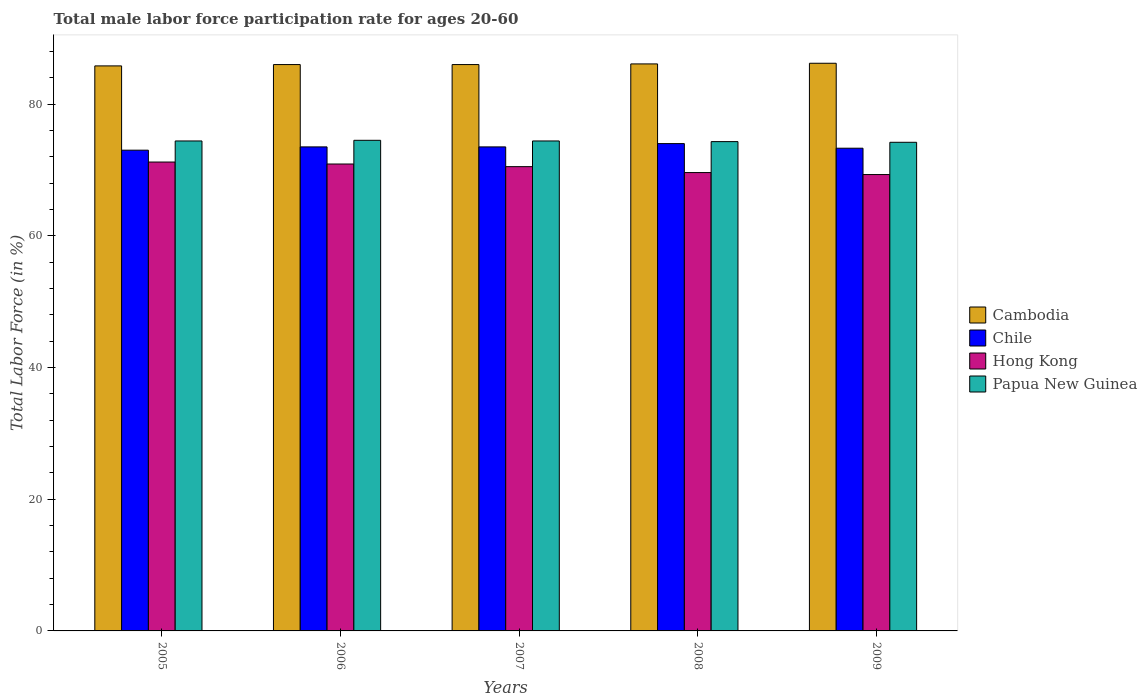How many different coloured bars are there?
Give a very brief answer. 4. How many bars are there on the 2nd tick from the right?
Offer a very short reply. 4. What is the label of the 1st group of bars from the left?
Keep it short and to the point. 2005. In how many cases, is the number of bars for a given year not equal to the number of legend labels?
Your answer should be very brief. 0. What is the male labor force participation rate in Hong Kong in 2006?
Your answer should be compact. 70.9. Across all years, what is the maximum male labor force participation rate in Cambodia?
Make the answer very short. 86.2. Across all years, what is the minimum male labor force participation rate in Chile?
Offer a very short reply. 73. In which year was the male labor force participation rate in Hong Kong minimum?
Your answer should be very brief. 2009. What is the total male labor force participation rate in Hong Kong in the graph?
Offer a terse response. 351.5. What is the difference between the male labor force participation rate in Cambodia in 2007 and that in 2009?
Keep it short and to the point. -0.2. What is the difference between the male labor force participation rate in Cambodia in 2008 and the male labor force participation rate in Chile in 2009?
Your answer should be compact. 12.8. What is the average male labor force participation rate in Cambodia per year?
Give a very brief answer. 86.02. In the year 2009, what is the difference between the male labor force participation rate in Papua New Guinea and male labor force participation rate in Hong Kong?
Offer a terse response. 4.9. What is the ratio of the male labor force participation rate in Cambodia in 2008 to that in 2009?
Provide a short and direct response. 1. Is the male labor force participation rate in Cambodia in 2005 less than that in 2006?
Ensure brevity in your answer.  Yes. What is the difference between the highest and the lowest male labor force participation rate in Papua New Guinea?
Offer a terse response. 0.3. Is the sum of the male labor force participation rate in Hong Kong in 2006 and 2009 greater than the maximum male labor force participation rate in Papua New Guinea across all years?
Provide a short and direct response. Yes. Is it the case that in every year, the sum of the male labor force participation rate in Papua New Guinea and male labor force participation rate in Cambodia is greater than the sum of male labor force participation rate in Chile and male labor force participation rate in Hong Kong?
Give a very brief answer. Yes. What does the 4th bar from the left in 2008 represents?
Your response must be concise. Papua New Guinea. What does the 4th bar from the right in 2009 represents?
Your response must be concise. Cambodia. How many bars are there?
Your answer should be very brief. 20. How many years are there in the graph?
Provide a succinct answer. 5. What is the difference between two consecutive major ticks on the Y-axis?
Provide a succinct answer. 20. Does the graph contain any zero values?
Your answer should be very brief. No. Where does the legend appear in the graph?
Offer a terse response. Center right. How are the legend labels stacked?
Give a very brief answer. Vertical. What is the title of the graph?
Keep it short and to the point. Total male labor force participation rate for ages 20-60. What is the label or title of the X-axis?
Give a very brief answer. Years. What is the Total Labor Force (in %) of Cambodia in 2005?
Your answer should be very brief. 85.8. What is the Total Labor Force (in %) of Chile in 2005?
Offer a terse response. 73. What is the Total Labor Force (in %) of Hong Kong in 2005?
Your answer should be very brief. 71.2. What is the Total Labor Force (in %) of Papua New Guinea in 2005?
Provide a short and direct response. 74.4. What is the Total Labor Force (in %) in Chile in 2006?
Ensure brevity in your answer.  73.5. What is the Total Labor Force (in %) of Hong Kong in 2006?
Offer a terse response. 70.9. What is the Total Labor Force (in %) in Papua New Guinea in 2006?
Your answer should be very brief. 74.5. What is the Total Labor Force (in %) in Chile in 2007?
Ensure brevity in your answer.  73.5. What is the Total Labor Force (in %) of Hong Kong in 2007?
Your response must be concise. 70.5. What is the Total Labor Force (in %) in Papua New Guinea in 2007?
Your answer should be very brief. 74.4. What is the Total Labor Force (in %) of Cambodia in 2008?
Offer a terse response. 86.1. What is the Total Labor Force (in %) of Hong Kong in 2008?
Provide a succinct answer. 69.6. What is the Total Labor Force (in %) of Papua New Guinea in 2008?
Provide a succinct answer. 74.3. What is the Total Labor Force (in %) in Cambodia in 2009?
Offer a terse response. 86.2. What is the Total Labor Force (in %) in Chile in 2009?
Ensure brevity in your answer.  73.3. What is the Total Labor Force (in %) in Hong Kong in 2009?
Provide a short and direct response. 69.3. What is the Total Labor Force (in %) of Papua New Guinea in 2009?
Provide a succinct answer. 74.2. Across all years, what is the maximum Total Labor Force (in %) of Cambodia?
Your answer should be very brief. 86.2. Across all years, what is the maximum Total Labor Force (in %) of Chile?
Make the answer very short. 74. Across all years, what is the maximum Total Labor Force (in %) in Hong Kong?
Ensure brevity in your answer.  71.2. Across all years, what is the maximum Total Labor Force (in %) of Papua New Guinea?
Provide a succinct answer. 74.5. Across all years, what is the minimum Total Labor Force (in %) of Cambodia?
Offer a terse response. 85.8. Across all years, what is the minimum Total Labor Force (in %) of Chile?
Make the answer very short. 73. Across all years, what is the minimum Total Labor Force (in %) of Hong Kong?
Keep it short and to the point. 69.3. Across all years, what is the minimum Total Labor Force (in %) in Papua New Guinea?
Your answer should be compact. 74.2. What is the total Total Labor Force (in %) of Cambodia in the graph?
Ensure brevity in your answer.  430.1. What is the total Total Labor Force (in %) of Chile in the graph?
Your answer should be very brief. 367.3. What is the total Total Labor Force (in %) of Hong Kong in the graph?
Make the answer very short. 351.5. What is the total Total Labor Force (in %) of Papua New Guinea in the graph?
Provide a succinct answer. 371.8. What is the difference between the Total Labor Force (in %) in Cambodia in 2005 and that in 2007?
Keep it short and to the point. -0.2. What is the difference between the Total Labor Force (in %) of Hong Kong in 2005 and that in 2007?
Offer a very short reply. 0.7. What is the difference between the Total Labor Force (in %) in Cambodia in 2005 and that in 2009?
Your response must be concise. -0.4. What is the difference between the Total Labor Force (in %) in Chile in 2005 and that in 2009?
Give a very brief answer. -0.3. What is the difference between the Total Labor Force (in %) in Hong Kong in 2005 and that in 2009?
Keep it short and to the point. 1.9. What is the difference between the Total Labor Force (in %) in Papua New Guinea in 2005 and that in 2009?
Keep it short and to the point. 0.2. What is the difference between the Total Labor Force (in %) of Chile in 2006 and that in 2007?
Provide a short and direct response. 0. What is the difference between the Total Labor Force (in %) of Chile in 2006 and that in 2008?
Your answer should be very brief. -0.5. What is the difference between the Total Labor Force (in %) in Hong Kong in 2006 and that in 2008?
Make the answer very short. 1.3. What is the difference between the Total Labor Force (in %) in Papua New Guinea in 2006 and that in 2008?
Keep it short and to the point. 0.2. What is the difference between the Total Labor Force (in %) in Chile in 2006 and that in 2009?
Offer a terse response. 0.2. What is the difference between the Total Labor Force (in %) of Hong Kong in 2006 and that in 2009?
Your answer should be very brief. 1.6. What is the difference between the Total Labor Force (in %) in Cambodia in 2007 and that in 2008?
Your response must be concise. -0.1. What is the difference between the Total Labor Force (in %) of Papua New Guinea in 2007 and that in 2008?
Offer a terse response. 0.1. What is the difference between the Total Labor Force (in %) in Cambodia in 2007 and that in 2009?
Make the answer very short. -0.2. What is the difference between the Total Labor Force (in %) in Chile in 2007 and that in 2009?
Your answer should be compact. 0.2. What is the difference between the Total Labor Force (in %) of Hong Kong in 2007 and that in 2009?
Give a very brief answer. 1.2. What is the difference between the Total Labor Force (in %) in Papua New Guinea in 2007 and that in 2009?
Your answer should be very brief. 0.2. What is the difference between the Total Labor Force (in %) in Papua New Guinea in 2008 and that in 2009?
Ensure brevity in your answer.  0.1. What is the difference between the Total Labor Force (in %) of Cambodia in 2005 and the Total Labor Force (in %) of Hong Kong in 2006?
Give a very brief answer. 14.9. What is the difference between the Total Labor Force (in %) of Cambodia in 2005 and the Total Labor Force (in %) of Hong Kong in 2007?
Provide a short and direct response. 15.3. What is the difference between the Total Labor Force (in %) of Cambodia in 2005 and the Total Labor Force (in %) of Papua New Guinea in 2007?
Offer a terse response. 11.4. What is the difference between the Total Labor Force (in %) in Chile in 2005 and the Total Labor Force (in %) in Papua New Guinea in 2007?
Offer a very short reply. -1.4. What is the difference between the Total Labor Force (in %) in Cambodia in 2005 and the Total Labor Force (in %) in Chile in 2008?
Your response must be concise. 11.8. What is the difference between the Total Labor Force (in %) of Cambodia in 2005 and the Total Labor Force (in %) of Hong Kong in 2008?
Offer a terse response. 16.2. What is the difference between the Total Labor Force (in %) of Chile in 2005 and the Total Labor Force (in %) of Papua New Guinea in 2008?
Your answer should be compact. -1.3. What is the difference between the Total Labor Force (in %) of Hong Kong in 2005 and the Total Labor Force (in %) of Papua New Guinea in 2008?
Provide a succinct answer. -3.1. What is the difference between the Total Labor Force (in %) of Cambodia in 2005 and the Total Labor Force (in %) of Hong Kong in 2009?
Your answer should be very brief. 16.5. What is the difference between the Total Labor Force (in %) of Cambodia in 2005 and the Total Labor Force (in %) of Papua New Guinea in 2009?
Keep it short and to the point. 11.6. What is the difference between the Total Labor Force (in %) in Chile in 2005 and the Total Labor Force (in %) in Papua New Guinea in 2009?
Keep it short and to the point. -1.2. What is the difference between the Total Labor Force (in %) in Cambodia in 2006 and the Total Labor Force (in %) in Papua New Guinea in 2007?
Provide a succinct answer. 11.6. What is the difference between the Total Labor Force (in %) of Chile in 2006 and the Total Labor Force (in %) of Papua New Guinea in 2007?
Give a very brief answer. -0.9. What is the difference between the Total Labor Force (in %) of Hong Kong in 2006 and the Total Labor Force (in %) of Papua New Guinea in 2007?
Keep it short and to the point. -3.5. What is the difference between the Total Labor Force (in %) in Chile in 2006 and the Total Labor Force (in %) in Hong Kong in 2008?
Provide a succinct answer. 3.9. What is the difference between the Total Labor Force (in %) in Cambodia in 2006 and the Total Labor Force (in %) in Papua New Guinea in 2009?
Your answer should be compact. 11.8. What is the difference between the Total Labor Force (in %) of Hong Kong in 2006 and the Total Labor Force (in %) of Papua New Guinea in 2009?
Make the answer very short. -3.3. What is the difference between the Total Labor Force (in %) of Chile in 2007 and the Total Labor Force (in %) of Hong Kong in 2008?
Give a very brief answer. 3.9. What is the difference between the Total Labor Force (in %) in Cambodia in 2007 and the Total Labor Force (in %) in Chile in 2009?
Provide a succinct answer. 12.7. What is the difference between the Total Labor Force (in %) in Cambodia in 2007 and the Total Labor Force (in %) in Hong Kong in 2009?
Make the answer very short. 16.7. What is the difference between the Total Labor Force (in %) in Hong Kong in 2007 and the Total Labor Force (in %) in Papua New Guinea in 2009?
Offer a very short reply. -3.7. What is the difference between the Total Labor Force (in %) in Cambodia in 2008 and the Total Labor Force (in %) in Chile in 2009?
Your answer should be very brief. 12.8. What is the difference between the Total Labor Force (in %) in Cambodia in 2008 and the Total Labor Force (in %) in Papua New Guinea in 2009?
Keep it short and to the point. 11.9. What is the difference between the Total Labor Force (in %) of Chile in 2008 and the Total Labor Force (in %) of Hong Kong in 2009?
Offer a very short reply. 4.7. What is the difference between the Total Labor Force (in %) in Hong Kong in 2008 and the Total Labor Force (in %) in Papua New Guinea in 2009?
Provide a succinct answer. -4.6. What is the average Total Labor Force (in %) in Cambodia per year?
Provide a short and direct response. 86.02. What is the average Total Labor Force (in %) in Chile per year?
Provide a succinct answer. 73.46. What is the average Total Labor Force (in %) in Hong Kong per year?
Provide a succinct answer. 70.3. What is the average Total Labor Force (in %) of Papua New Guinea per year?
Your answer should be very brief. 74.36. In the year 2005, what is the difference between the Total Labor Force (in %) in Cambodia and Total Labor Force (in %) in Chile?
Give a very brief answer. 12.8. In the year 2006, what is the difference between the Total Labor Force (in %) in Cambodia and Total Labor Force (in %) in Hong Kong?
Your response must be concise. 15.1. In the year 2006, what is the difference between the Total Labor Force (in %) of Cambodia and Total Labor Force (in %) of Papua New Guinea?
Make the answer very short. 11.5. In the year 2006, what is the difference between the Total Labor Force (in %) of Chile and Total Labor Force (in %) of Papua New Guinea?
Provide a short and direct response. -1. In the year 2007, what is the difference between the Total Labor Force (in %) of Cambodia and Total Labor Force (in %) of Hong Kong?
Offer a terse response. 15.5. In the year 2007, what is the difference between the Total Labor Force (in %) in Chile and Total Labor Force (in %) in Papua New Guinea?
Offer a very short reply. -0.9. In the year 2007, what is the difference between the Total Labor Force (in %) in Hong Kong and Total Labor Force (in %) in Papua New Guinea?
Offer a very short reply. -3.9. In the year 2008, what is the difference between the Total Labor Force (in %) of Cambodia and Total Labor Force (in %) of Papua New Guinea?
Keep it short and to the point. 11.8. In the year 2008, what is the difference between the Total Labor Force (in %) in Chile and Total Labor Force (in %) in Hong Kong?
Offer a very short reply. 4.4. In the year 2008, what is the difference between the Total Labor Force (in %) of Chile and Total Labor Force (in %) of Papua New Guinea?
Your response must be concise. -0.3. In the year 2008, what is the difference between the Total Labor Force (in %) in Hong Kong and Total Labor Force (in %) in Papua New Guinea?
Your answer should be compact. -4.7. In the year 2009, what is the difference between the Total Labor Force (in %) in Cambodia and Total Labor Force (in %) in Chile?
Your response must be concise. 12.9. In the year 2009, what is the difference between the Total Labor Force (in %) of Cambodia and Total Labor Force (in %) of Papua New Guinea?
Provide a succinct answer. 12. In the year 2009, what is the difference between the Total Labor Force (in %) in Chile and Total Labor Force (in %) in Hong Kong?
Give a very brief answer. 4. What is the ratio of the Total Labor Force (in %) in Hong Kong in 2005 to that in 2006?
Keep it short and to the point. 1. What is the ratio of the Total Labor Force (in %) of Papua New Guinea in 2005 to that in 2006?
Your response must be concise. 1. What is the ratio of the Total Labor Force (in %) of Hong Kong in 2005 to that in 2007?
Provide a succinct answer. 1.01. What is the ratio of the Total Labor Force (in %) in Chile in 2005 to that in 2008?
Offer a very short reply. 0.99. What is the ratio of the Total Labor Force (in %) of Cambodia in 2005 to that in 2009?
Your response must be concise. 1. What is the ratio of the Total Labor Force (in %) of Hong Kong in 2005 to that in 2009?
Provide a succinct answer. 1.03. What is the ratio of the Total Labor Force (in %) of Papua New Guinea in 2005 to that in 2009?
Your response must be concise. 1. What is the ratio of the Total Labor Force (in %) in Cambodia in 2006 to that in 2008?
Make the answer very short. 1. What is the ratio of the Total Labor Force (in %) of Chile in 2006 to that in 2008?
Provide a succinct answer. 0.99. What is the ratio of the Total Labor Force (in %) in Hong Kong in 2006 to that in 2008?
Offer a very short reply. 1.02. What is the ratio of the Total Labor Force (in %) in Papua New Guinea in 2006 to that in 2008?
Your response must be concise. 1. What is the ratio of the Total Labor Force (in %) in Cambodia in 2006 to that in 2009?
Your answer should be compact. 1. What is the ratio of the Total Labor Force (in %) in Hong Kong in 2006 to that in 2009?
Offer a terse response. 1.02. What is the ratio of the Total Labor Force (in %) in Chile in 2007 to that in 2008?
Provide a succinct answer. 0.99. What is the ratio of the Total Labor Force (in %) in Hong Kong in 2007 to that in 2008?
Keep it short and to the point. 1.01. What is the ratio of the Total Labor Force (in %) of Cambodia in 2007 to that in 2009?
Offer a terse response. 1. What is the ratio of the Total Labor Force (in %) of Chile in 2007 to that in 2009?
Ensure brevity in your answer.  1. What is the ratio of the Total Labor Force (in %) in Hong Kong in 2007 to that in 2009?
Your answer should be compact. 1.02. What is the ratio of the Total Labor Force (in %) in Chile in 2008 to that in 2009?
Offer a terse response. 1.01. What is the difference between the highest and the second highest Total Labor Force (in %) of Cambodia?
Keep it short and to the point. 0.1. What is the difference between the highest and the second highest Total Labor Force (in %) in Hong Kong?
Give a very brief answer. 0.3. What is the difference between the highest and the second highest Total Labor Force (in %) of Papua New Guinea?
Your answer should be compact. 0.1. What is the difference between the highest and the lowest Total Labor Force (in %) of Cambodia?
Make the answer very short. 0.4. 